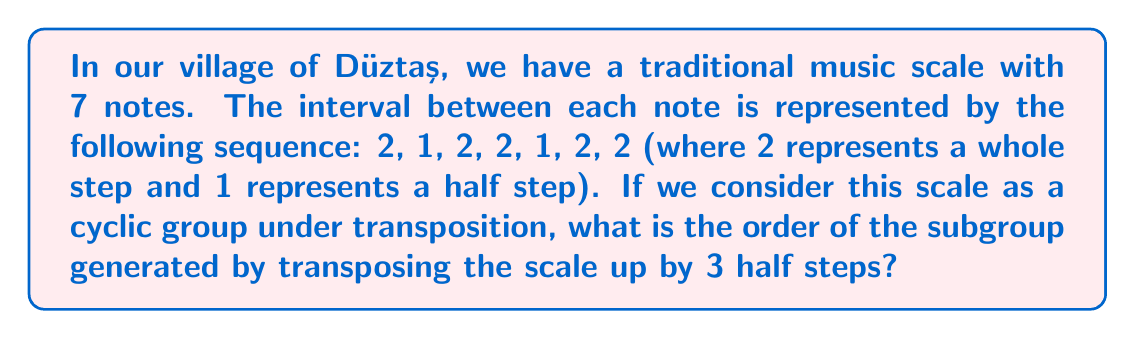Solve this math problem. Let's approach this step-by-step:

1) First, we need to understand what the question is asking. We're treating our scale as a cyclic group under transposition, where each element of the group is a different starting point of the scale.

2) The total number of half steps in our scale is:
   $$2 + 1 + 2 + 2 + 1 + 2 + 2 = 12$$
   This means our group has 12 elements, corresponding to the 12 possible starting points.

3) We're asked about the subgroup generated by transposing up by 3 half steps. In group theory terms, we're looking for the order of the element "3" in our group of 12 elements.

4) To find this, we need to determine how many times we need to apply the 3-half-step transposition to get back to our starting point. Mathematically, we're solving:
   $$3x \equiv 0 \pmod{12}$$

5) We can solve this by listing out the multiples of 3 modulo 12:
   3 ≡ 3 (mod 12)
   6 ≡ 6 (mod 12)
   9 ≡ 9 (mod 12)
   12 ≡ 0 (mod 12)

6) We see that it takes 4 applications of the 3-half-step transposition to return to our starting point.

7) In group theory terms, the order of the element "3" in our group is 4.
Answer: The order of the subgroup generated by transposing the scale up by 3 half steps is 4. 